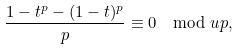<formula> <loc_0><loc_0><loc_500><loc_500>\frac { 1 - t ^ { p } - ( 1 - t ) ^ { p } } { p } \equiv 0 \mod u p ,</formula> 